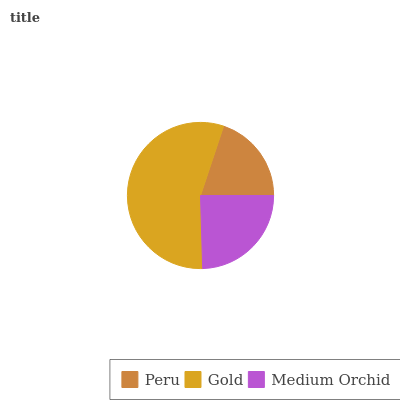Is Peru the minimum?
Answer yes or no. Yes. Is Gold the maximum?
Answer yes or no. Yes. Is Medium Orchid the minimum?
Answer yes or no. No. Is Medium Orchid the maximum?
Answer yes or no. No. Is Gold greater than Medium Orchid?
Answer yes or no. Yes. Is Medium Orchid less than Gold?
Answer yes or no. Yes. Is Medium Orchid greater than Gold?
Answer yes or no. No. Is Gold less than Medium Orchid?
Answer yes or no. No. Is Medium Orchid the high median?
Answer yes or no. Yes. Is Medium Orchid the low median?
Answer yes or no. Yes. Is Gold the high median?
Answer yes or no. No. Is Gold the low median?
Answer yes or no. No. 